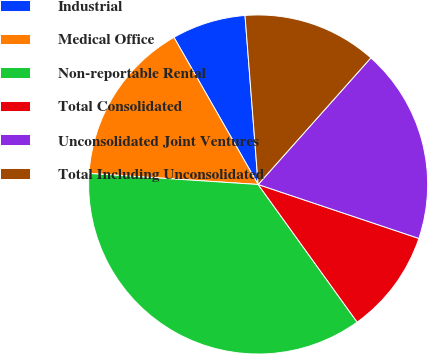<chart> <loc_0><loc_0><loc_500><loc_500><pie_chart><fcel>Industrial<fcel>Medical Office<fcel>Non-reportable Rental<fcel>Total Consolidated<fcel>Unconsolidated Joint Ventures<fcel>Total Including Unconsolidated<nl><fcel>7.04%<fcel>15.69%<fcel>35.97%<fcel>9.92%<fcel>18.58%<fcel>12.81%<nl></chart> 